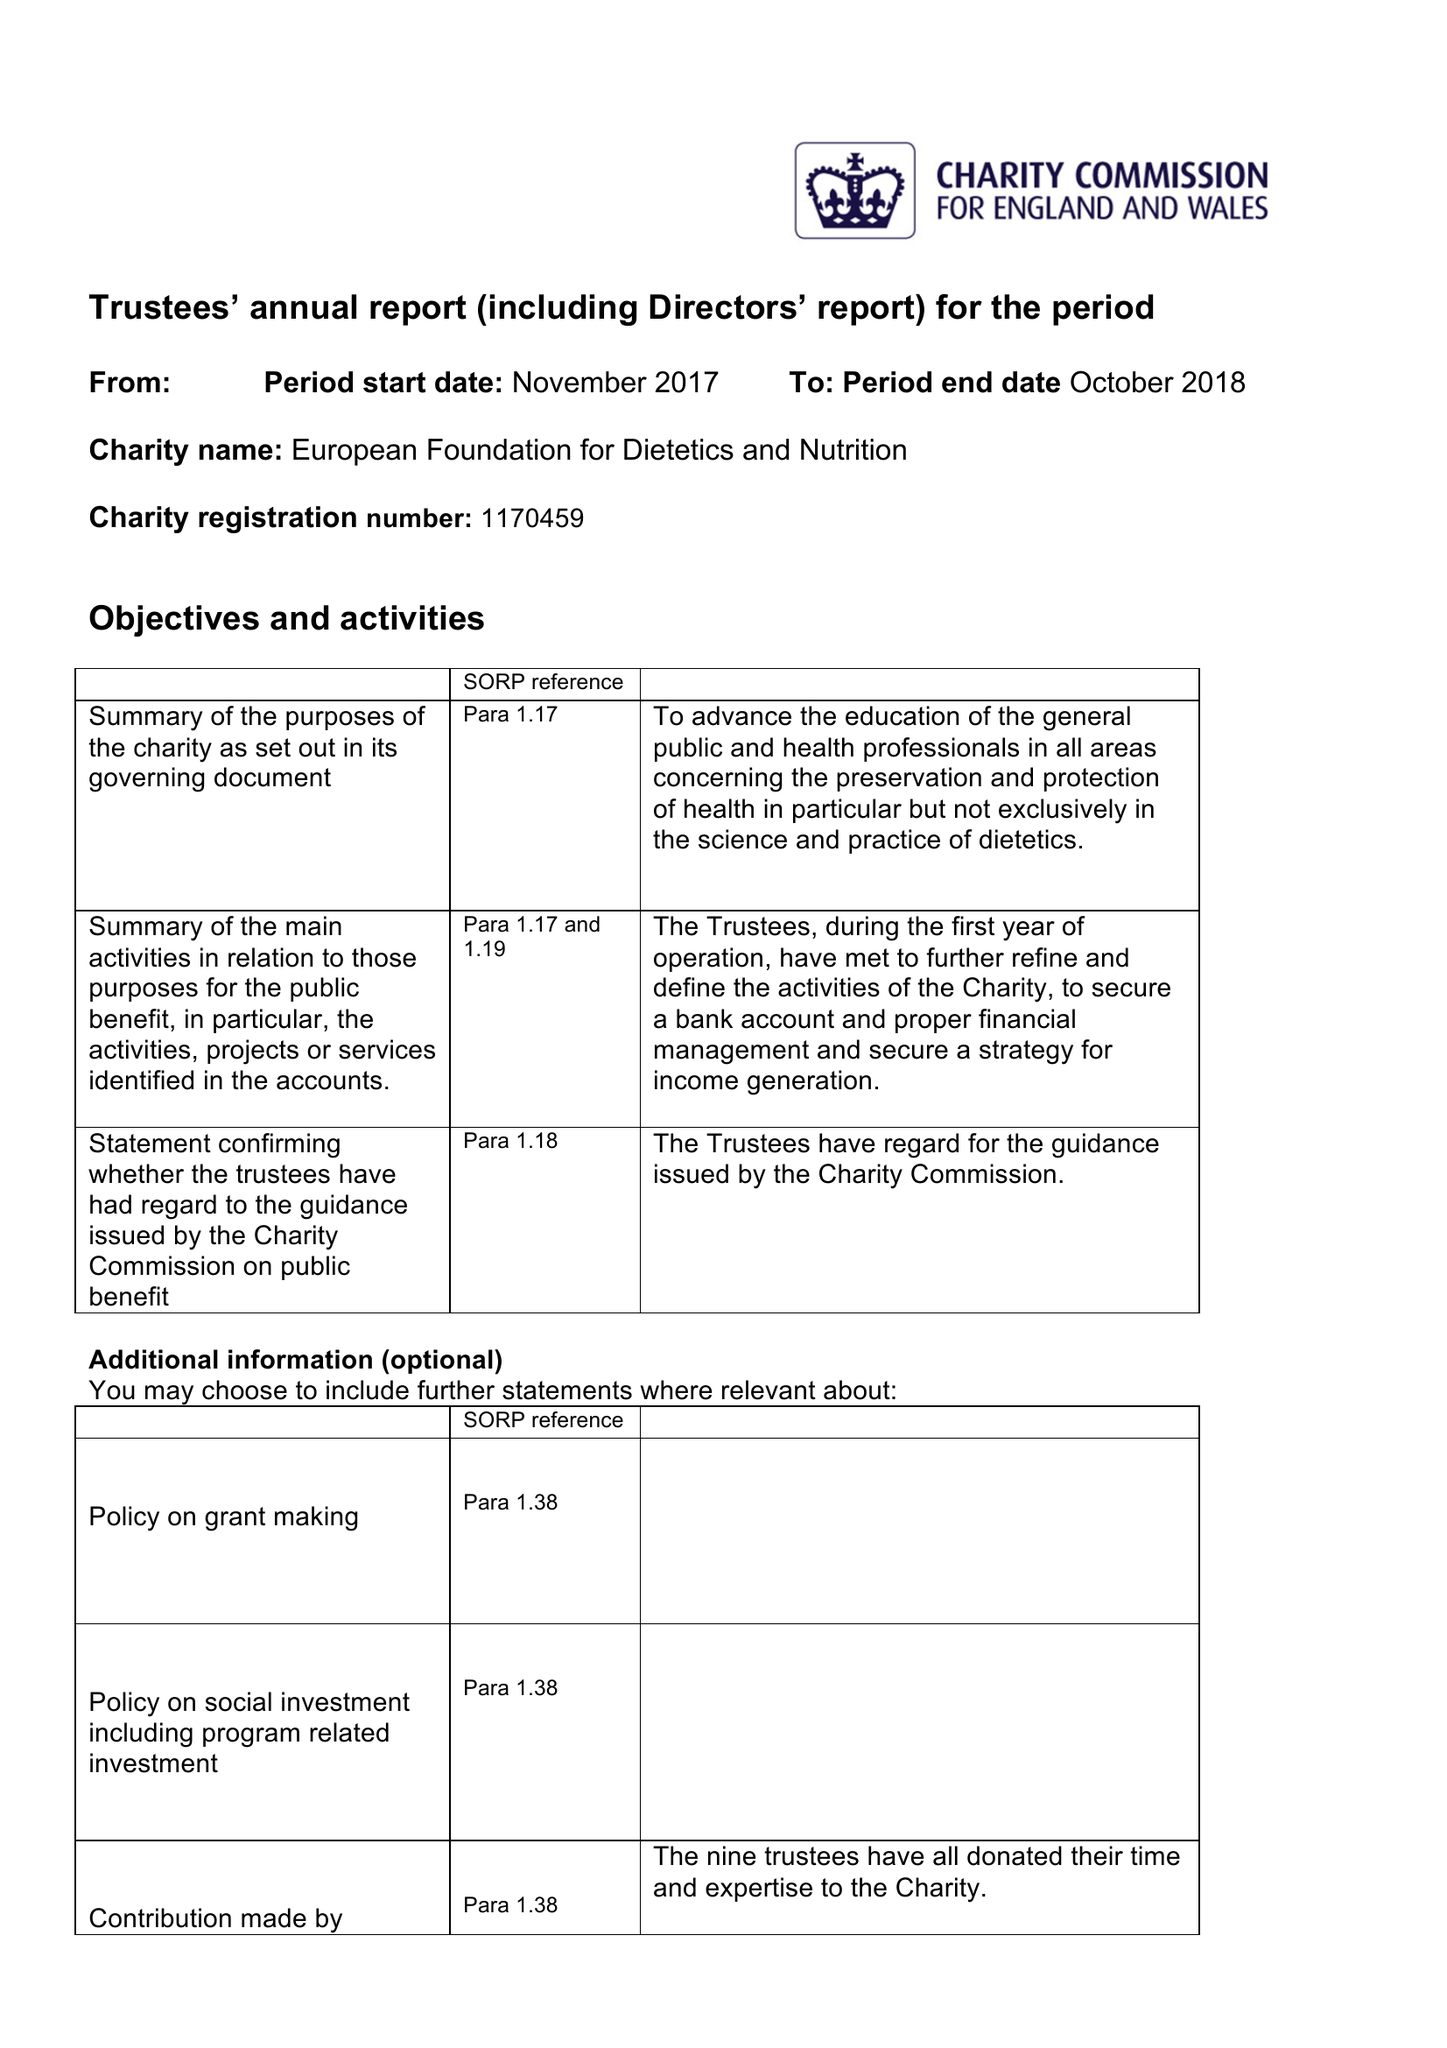What is the value for the address__postcode?
Answer the question using a single word or phrase. B3 3HT 